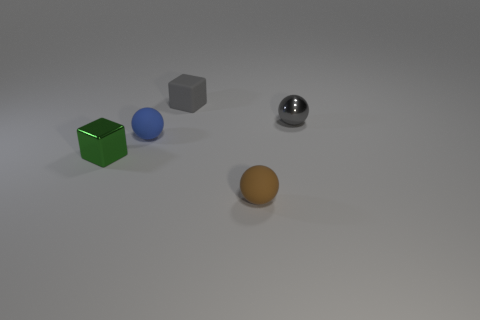Subtract all blue balls. How many balls are left? 2 Subtract all cubes. How many objects are left? 3 Add 1 large yellow metallic blocks. How many objects exist? 6 Subtract all blue balls. How many balls are left? 2 Subtract 2 cubes. How many cubes are left? 0 Subtract all green metallic things. Subtract all metal cubes. How many objects are left? 3 Add 1 small gray spheres. How many small gray spheres are left? 2 Add 3 metallic things. How many metallic things exist? 5 Subtract 0 cyan balls. How many objects are left? 5 Subtract all gray spheres. Subtract all green cylinders. How many spheres are left? 2 